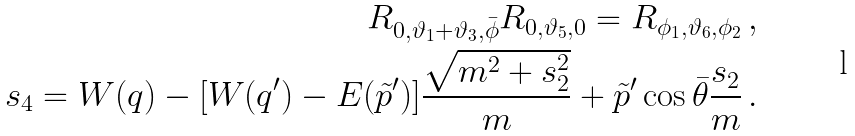<formula> <loc_0><loc_0><loc_500><loc_500>R _ { 0 , \vartheta _ { 1 } + \vartheta _ { 3 } , \bar { \phi } } R _ { 0 , \vartheta _ { 5 } , 0 } = R _ { \phi _ { 1 } , \vartheta _ { 6 } , \phi _ { 2 } } \, , \\ s _ { 4 } = W ( q ) - [ W ( q ^ { \prime } ) - E ( \tilde { p } ^ { \prime } ) ] \frac { \sqrt { m ^ { 2 } + s ^ { 2 } _ { 2 } } } { m } + \tilde { p } ^ { \prime } \cos \bar { \theta } \frac { s _ { 2 } } { m } \, .</formula> 